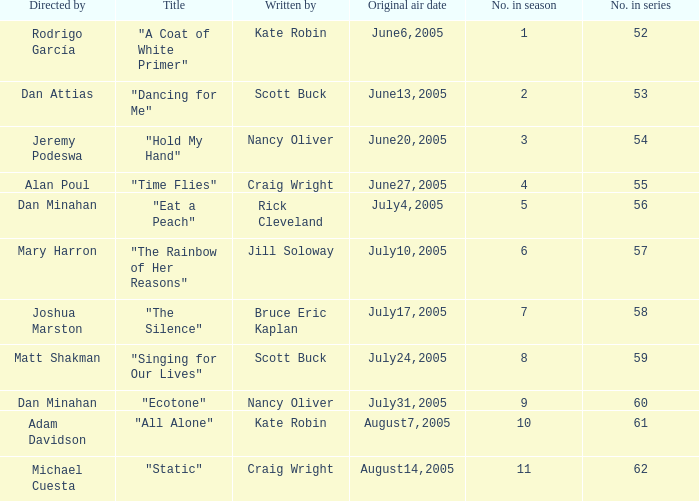What was the name of the episode that was directed by Mary Harron? "The Rainbow of Her Reasons". 